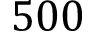Convert formula to latex. <formula><loc_0><loc_0><loc_500><loc_500>5 0 0</formula> 